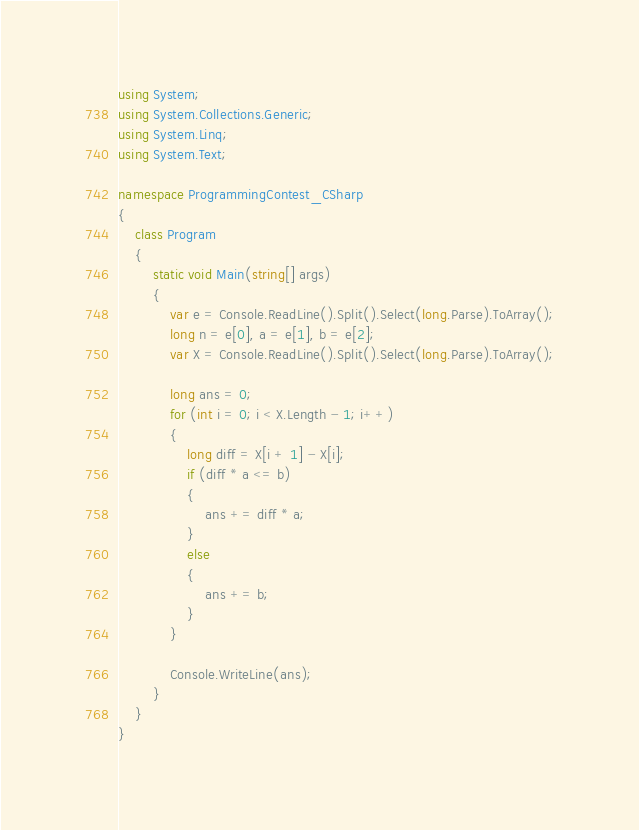Convert code to text. <code><loc_0><loc_0><loc_500><loc_500><_C#_>using System;
using System.Collections.Generic;
using System.Linq;
using System.Text;

namespace ProgrammingContest_CSharp
{
    class Program
    {
        static void Main(string[] args)
        {
            var e = Console.ReadLine().Split().Select(long.Parse).ToArray();
            long n = e[0], a = e[1], b = e[2];
            var X = Console.ReadLine().Split().Select(long.Parse).ToArray();

            long ans = 0;
            for (int i = 0; i < X.Length - 1; i++)
            {
                long diff = X[i + 1] - X[i];
                if (diff * a <= b)
                {
                    ans += diff * a;
                }
                else
                {
                    ans += b;
                }
            }

            Console.WriteLine(ans);
        }
    }
}
</code> 